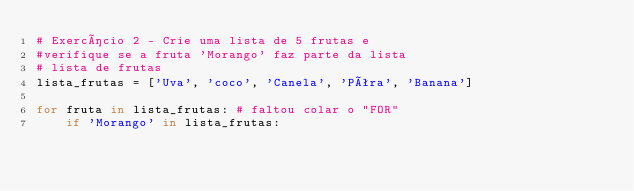Convert code to text. <code><loc_0><loc_0><loc_500><loc_500><_Python_># Exercício 2 - Crie uma lista de 5 frutas e
#verifique se a fruta 'Morango' faz parte da lista
# lista de frutas
lista_frutas = ['Uva', 'coco', 'Canela', 'Pêra', 'Banana']

for fruta in lista_frutas: # faltou colar o "FOR"
    if 'Morango' in lista_frutas:</code> 